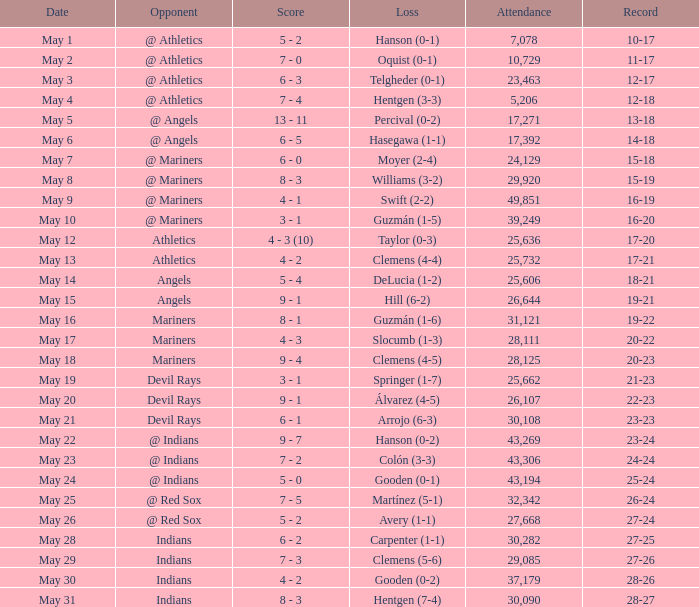What is the overall attendance count for record 25-24? 1.0. 